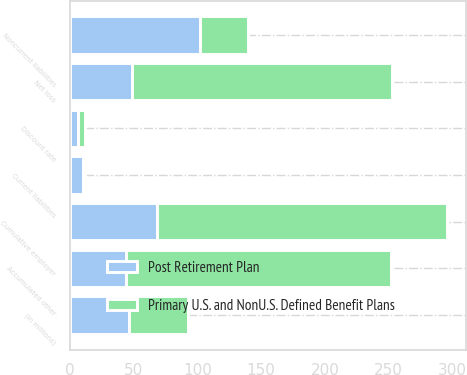Convert chart to OTSL. <chart><loc_0><loc_0><loc_500><loc_500><stacked_bar_chart><ecel><fcel>(In millions)<fcel>Current liabilities<fcel>Noncurrent liabilities<fcel>Net loss<fcel>Accumulated other<fcel>Cumulative employer<fcel>Discount rate<nl><fcel>Primary U.S. and NonU.S. Defined Benefit Plans<fcel>46.5<fcel>2<fcel>38<fcel>204<fcel>208<fcel>228<fcel>6<nl><fcel>Post Retirement Plan<fcel>46.5<fcel>10<fcel>102<fcel>49<fcel>44<fcel>68<fcel>6<nl></chart> 